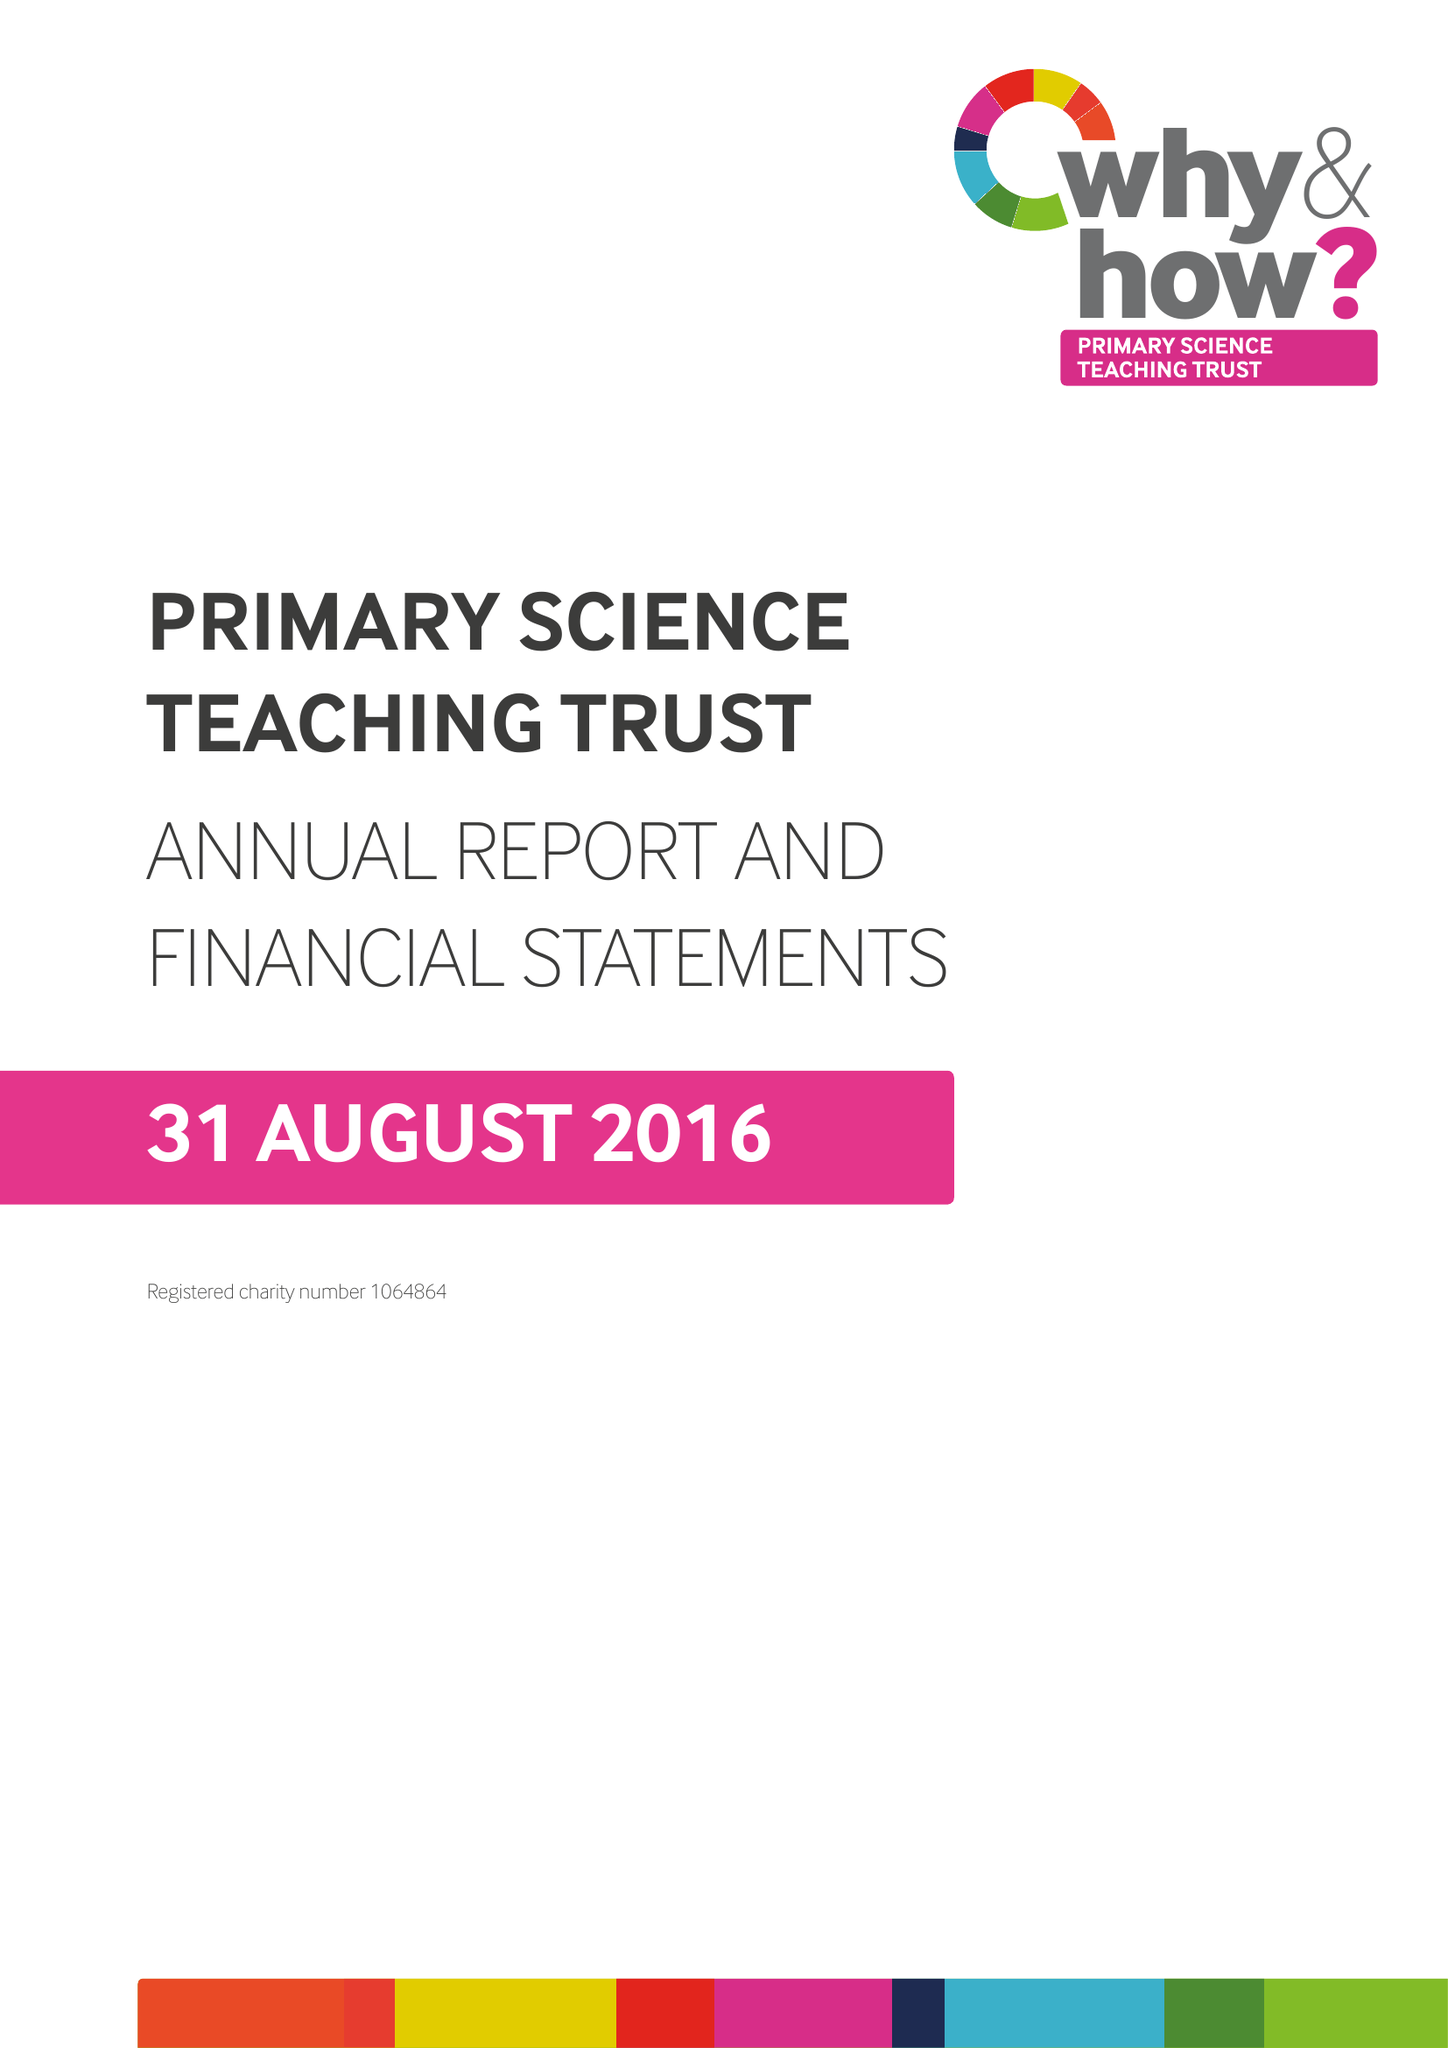What is the value for the income_annually_in_british_pounds?
Answer the question using a single word or phrase. 300280.00 